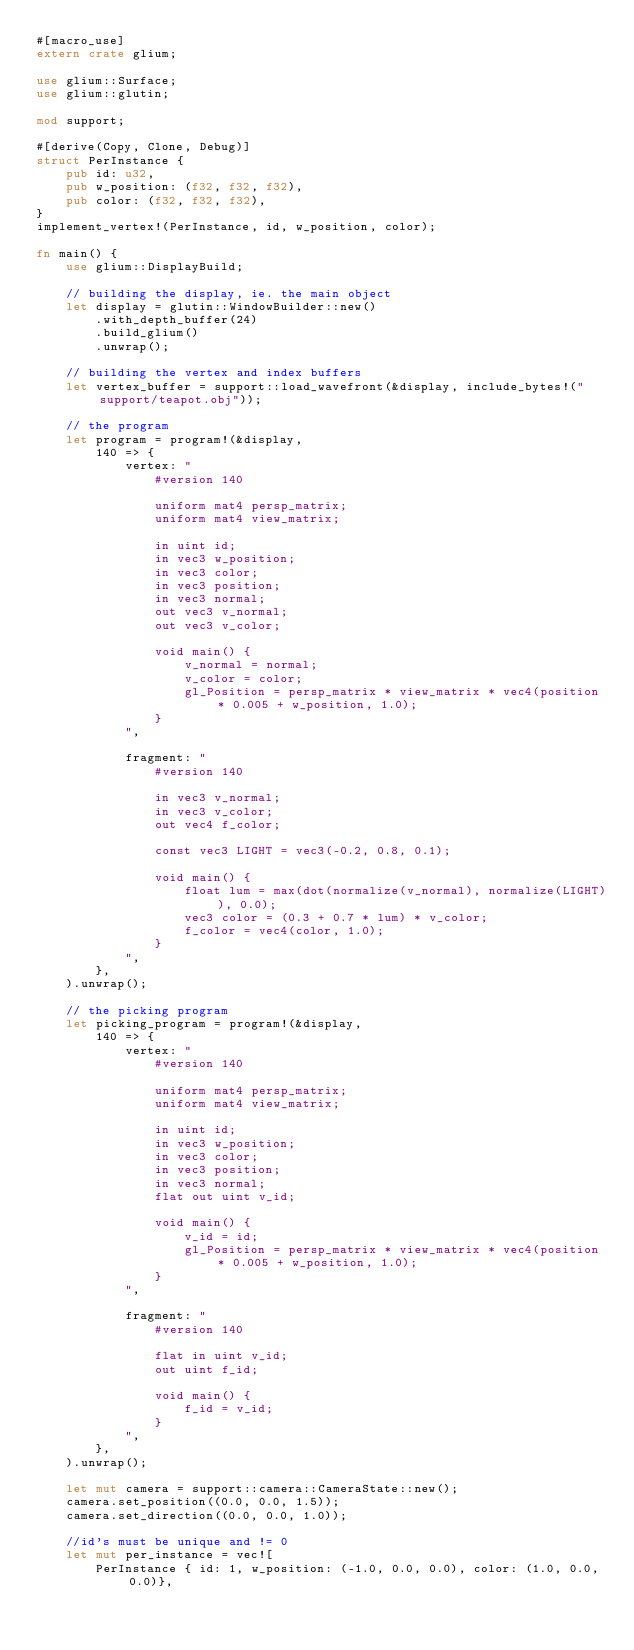<code> <loc_0><loc_0><loc_500><loc_500><_Rust_>#[macro_use]
extern crate glium;

use glium::Surface;
use glium::glutin;

mod support;

#[derive(Copy, Clone, Debug)]
struct PerInstance {
    pub id: u32,
    pub w_position: (f32, f32, f32),
    pub color: (f32, f32, f32),
}
implement_vertex!(PerInstance, id, w_position, color);

fn main() {
    use glium::DisplayBuild;

    // building the display, ie. the main object
    let display = glutin::WindowBuilder::new()
        .with_depth_buffer(24)
        .build_glium()
        .unwrap();

    // building the vertex and index buffers
    let vertex_buffer = support::load_wavefront(&display, include_bytes!("support/teapot.obj"));

    // the program
    let program = program!(&display,
        140 => {
            vertex: "
                #version 140

                uniform mat4 persp_matrix;
                uniform mat4 view_matrix;

                in uint id;
                in vec3 w_position;
                in vec3 color;
                in vec3 position;
                in vec3 normal;
                out vec3 v_normal;
                out vec3 v_color;

                void main() {
                    v_normal = normal;
                    v_color = color;
                    gl_Position = persp_matrix * view_matrix * vec4(position * 0.005 + w_position, 1.0);
                }
            ",

            fragment: "
                #version 140

                in vec3 v_normal;
                in vec3 v_color;
                out vec4 f_color;

                const vec3 LIGHT = vec3(-0.2, 0.8, 0.1);

                void main() {
                    float lum = max(dot(normalize(v_normal), normalize(LIGHT)), 0.0);
                    vec3 color = (0.3 + 0.7 * lum) * v_color;
                    f_color = vec4(color, 1.0);
                }
            ",
        },
    ).unwrap();

    // the picking program
    let picking_program = program!(&display,
        140 => {
            vertex: "
                #version 140

                uniform mat4 persp_matrix;
                uniform mat4 view_matrix;

                in uint id;
                in vec3 w_position;
                in vec3 color;
                in vec3 position;
                in vec3 normal;
                flat out uint v_id;

                void main() {
                    v_id = id;
                    gl_Position = persp_matrix * view_matrix * vec4(position * 0.005 + w_position, 1.0);
                }
            ",

            fragment: "
                #version 140

                flat in uint v_id;
                out uint f_id;

                void main() {
                    f_id = v_id;
                }
            ",
        },
    ).unwrap();

    let mut camera = support::camera::CameraState::new();
    camera.set_position((0.0, 0.0, 1.5));
    camera.set_direction((0.0, 0.0, 1.0));

    //id's must be unique and != 0
    let mut per_instance = vec![
        PerInstance { id: 1, w_position: (-1.0, 0.0, 0.0), color: (1.0, 0.0, 0.0)},</code> 